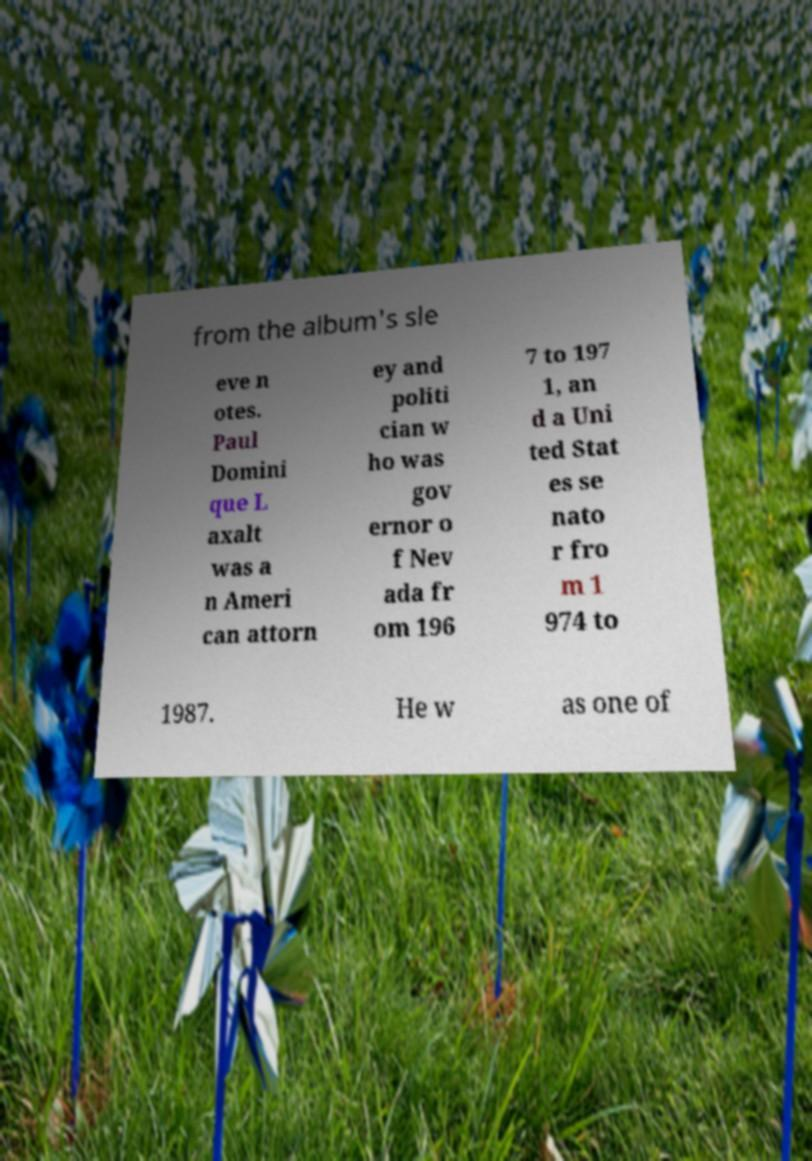Can you accurately transcribe the text from the provided image for me? from the album's sle eve n otes. Paul Domini que L axalt was a n Ameri can attorn ey and politi cian w ho was gov ernor o f Nev ada fr om 196 7 to 197 1, an d a Uni ted Stat es se nato r fro m 1 974 to 1987. He w as one of 